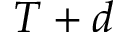<formula> <loc_0><loc_0><loc_500><loc_500>T + d</formula> 